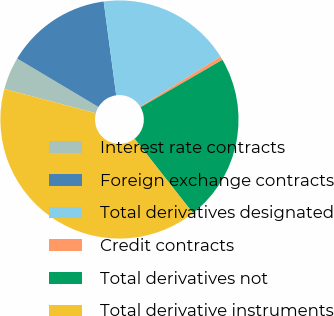Convert chart to OTSL. <chart><loc_0><loc_0><loc_500><loc_500><pie_chart><fcel>Interest rate contracts<fcel>Foreign exchange contracts<fcel>Total derivatives designated<fcel>Credit contracts<fcel>Total derivatives not<fcel>Total derivative instruments<nl><fcel>4.42%<fcel>14.33%<fcel>18.25%<fcel>0.5%<fcel>22.77%<fcel>39.73%<nl></chart> 